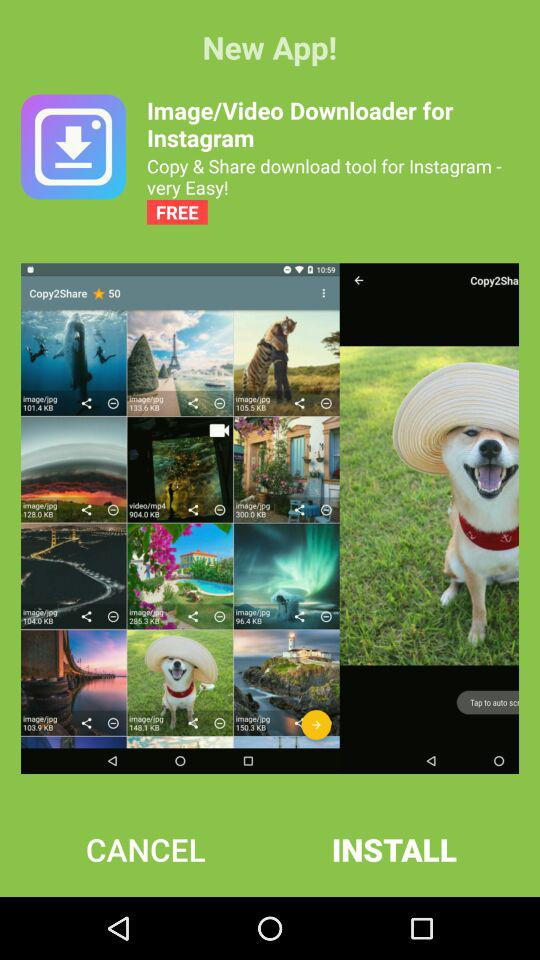What is the name of the application? The name of the application is "Image/Video Downloader for Instagram". 